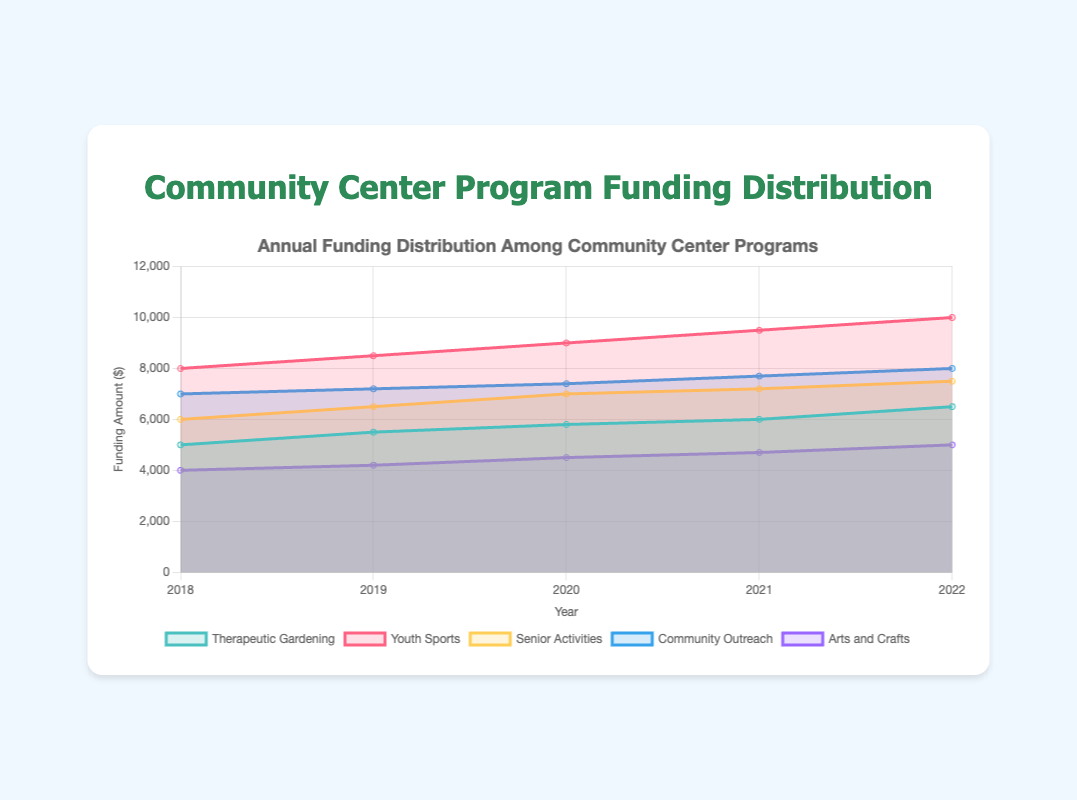how did funding for Therapeutic Gardening change from 2018 to 2022? Funding for Therapeutic Gardening increased from $5000 in 2018 to $6500 in 2022. To see this, observe the height of the "Therapeutic Gardening" area in 2018 and 2022 on the chart.
Answer: Increased by $1500 What was the total funding for all programs in 2020? Sum the funding amounts for all programs in 2020: Therapeutic Gardening ($5800) + Youth Sports ($9000) + Senior Activities ($7000) + Community Outreach ($7400) + Arts and Crafts ($4500). The sum is 5800 + 9000 + 7000 + 7400 + 4500 = 33700.
Answer: $33700 Which program had the highest funding in 2021? The program "Youth Sports" had the highest funding in 2021 with $9500. Look at the different areas in 2021, and the "Youth Sports" area's upper boundary is higher than the others'.
Answer: Youth Sports How did the funding for Arts and Crafts change over the years? The funding for Arts and Crafts increased steadily every year: $4000 in 2018, $4200 in 2019, $4500 in 2020, $4700 in 2021, and $5000 in 2022. Check the respective heights in the graph.
Answer: Increased steadily Compare the funding trends of Therapeutic Gardening and Senior Activities from 2018 to 2022. Funding for both programs increased over the years. Therapeutic Gardening went from $5000 to $6500, while Senior Activities went from $6000 to $7500. However, Therapeutic Gardening's increase was more gradual, whereas Senior Activities had slight jumps in funding. Compare the areas for both programs year by year.
Answer: Both increased, but Therapeutic Gardening's increase was more gradual What was the average funding for Community Outreach over the five years? Calculate the average by summing the funding amounts for Community Outreach from 2018 to 2022 and dividing by 5: ($7000 + $7200 + $7400 + $7700 + $8000) / 5. That is (7000 + 7200 + 7400 + 7700 + 8000) / 5 = 37300 / 5 = 7460.
Answer: $7460 Which year had the highest overall funding across all programs? Add the funding amounts of all programs for each year to find the highest total. For 2018, total is 5000 + 8000 + 6000 + 7000 + 4000 = 30000. Similarly, calculate for other years and find that 2022 has the highest overall: 6500 + 10000 + 7500 + 8000 + 5000 = 37000.
Answer: 2022 How does the funding for Youth Sports compare to Therapeutic Gardening in 2022? In 2022, Youth Sports received $10000 while Therapeutic Gardening received $6500. Youth Sports' funding is significantly higher. Compare the upper boundaries of the respective areas for 2022.
Answer: Youth Sports is higher by $3500 